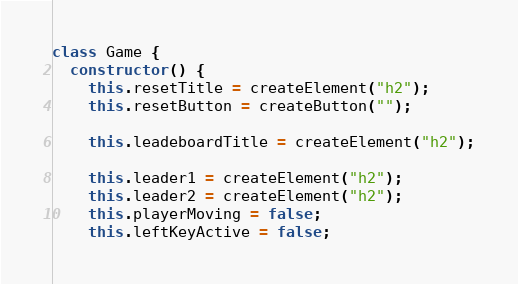Convert code to text. <code><loc_0><loc_0><loc_500><loc_500><_JavaScript_>class Game {
  constructor() {
    this.resetTitle = createElement("h2");
    this.resetButton = createButton("");

    this.leadeboardTitle = createElement("h2");

    this.leader1 = createElement("h2");
    this.leader2 = createElement("h2");
    this.playerMoving = false;
    this.leftKeyActive = false;</code> 